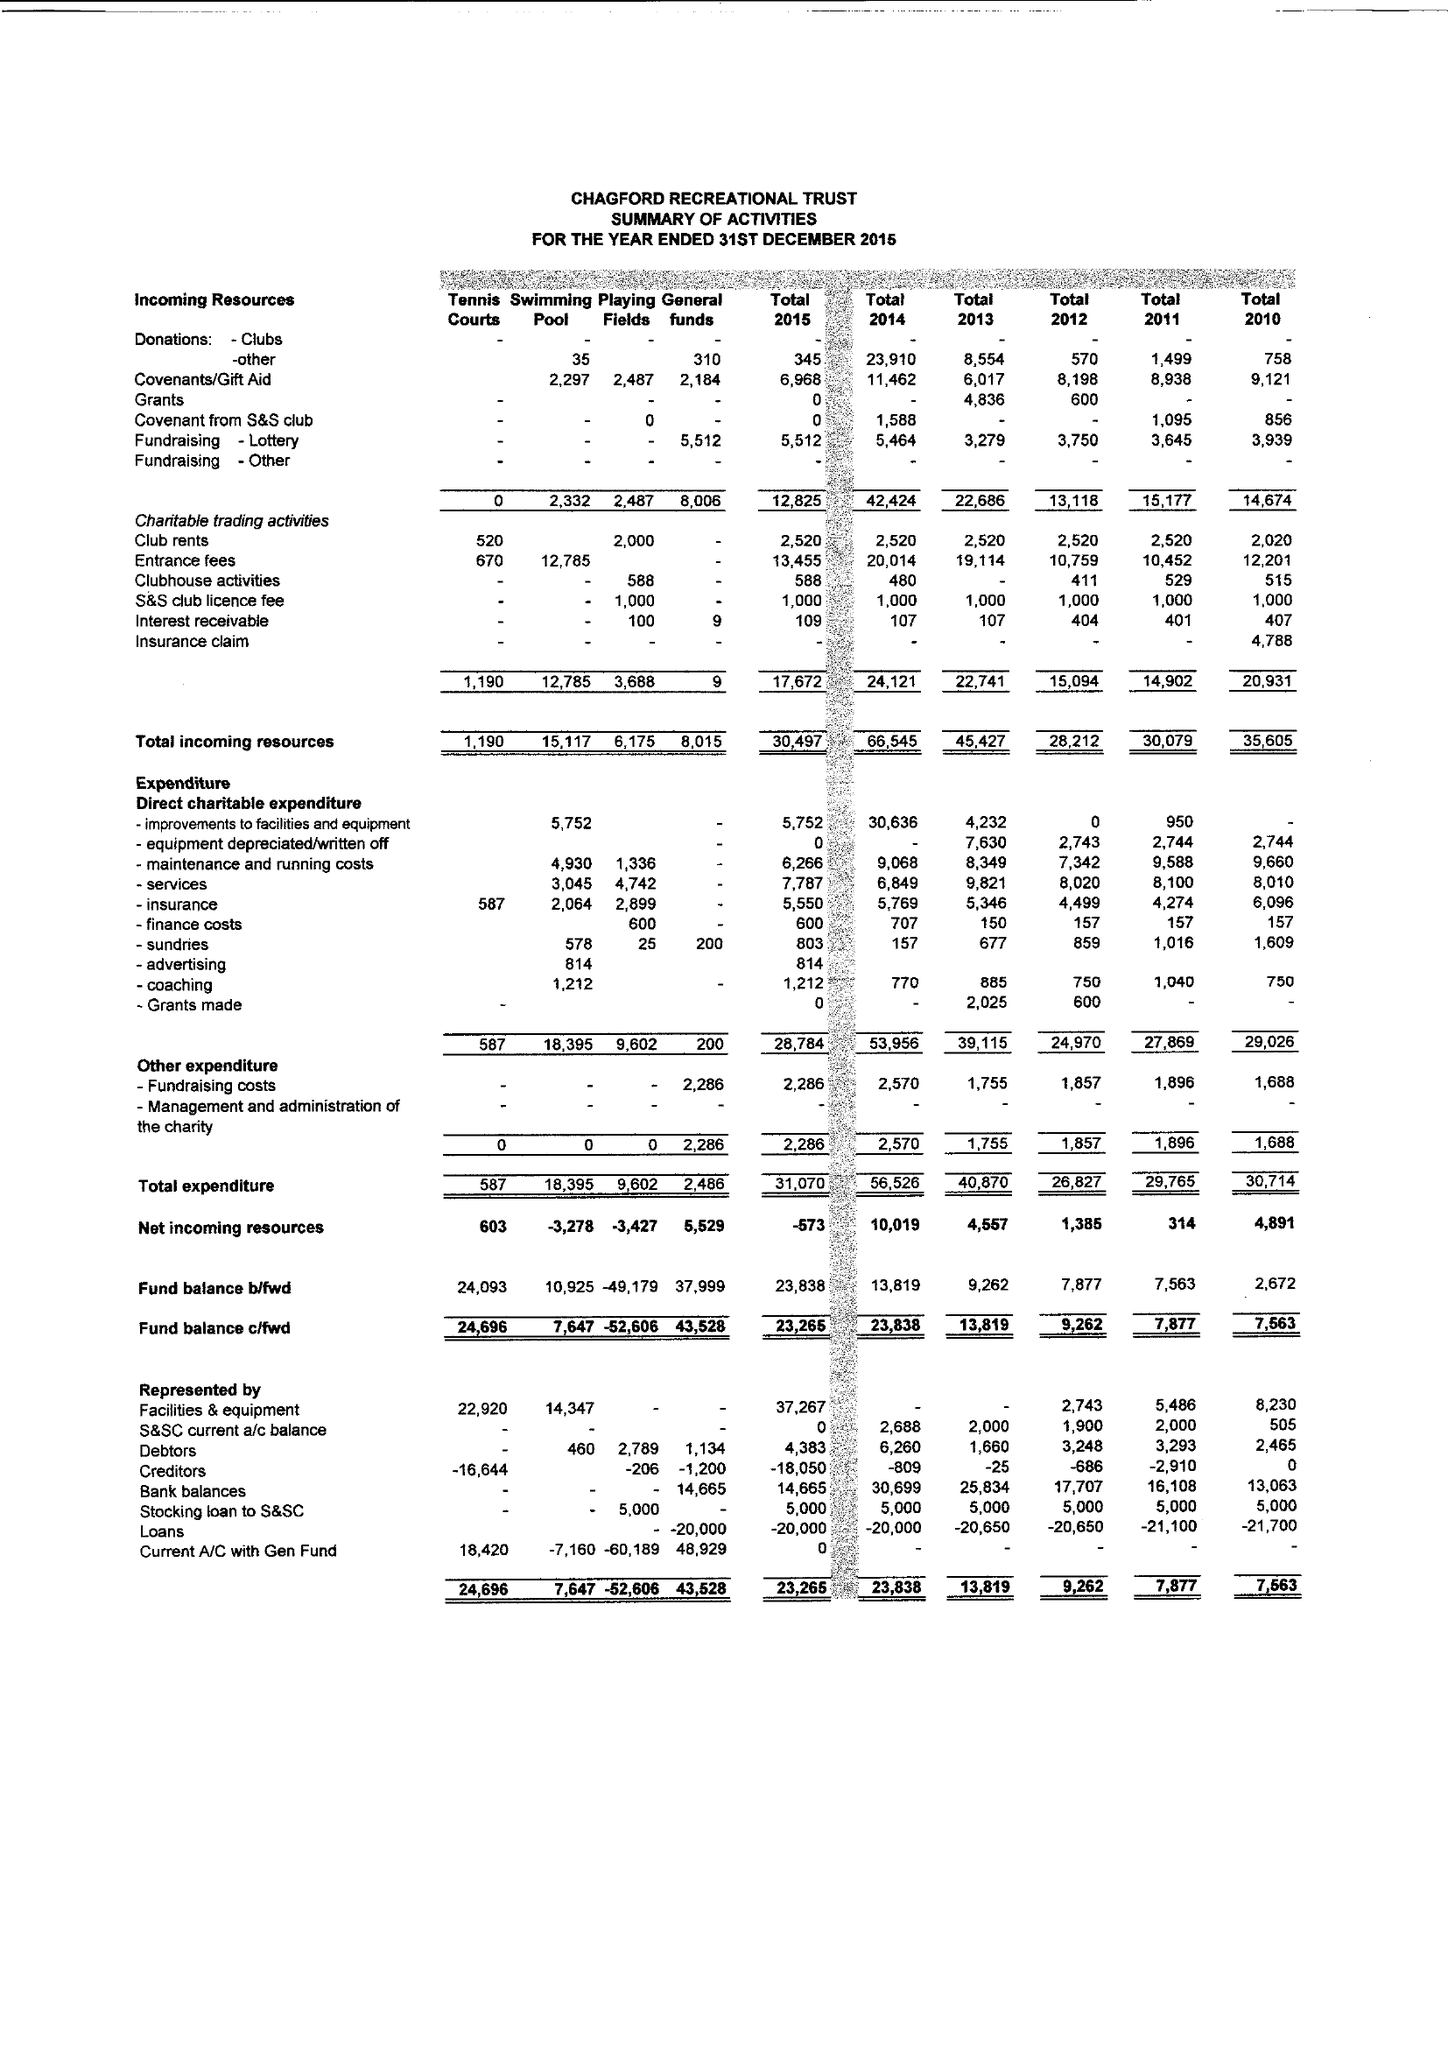What is the value for the spending_annually_in_british_pounds?
Answer the question using a single word or phrase. 31070.00 